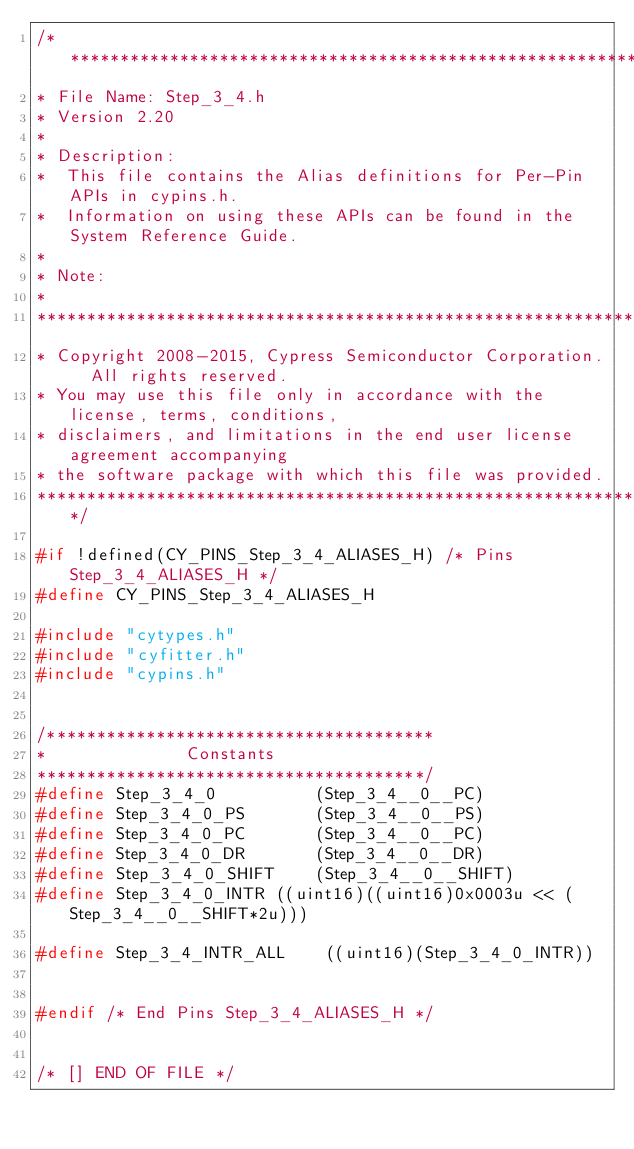Convert code to text. <code><loc_0><loc_0><loc_500><loc_500><_C_>/*******************************************************************************
* File Name: Step_3_4.h  
* Version 2.20
*
* Description:
*  This file contains the Alias definitions for Per-Pin APIs in cypins.h. 
*  Information on using these APIs can be found in the System Reference Guide.
*
* Note:
*
********************************************************************************
* Copyright 2008-2015, Cypress Semiconductor Corporation.  All rights reserved.
* You may use this file only in accordance with the license, terms, conditions, 
* disclaimers, and limitations in the end user license agreement accompanying 
* the software package with which this file was provided.
*******************************************************************************/

#if !defined(CY_PINS_Step_3_4_ALIASES_H) /* Pins Step_3_4_ALIASES_H */
#define CY_PINS_Step_3_4_ALIASES_H

#include "cytypes.h"
#include "cyfitter.h"
#include "cypins.h"


/***************************************
*              Constants        
***************************************/
#define Step_3_4_0			(Step_3_4__0__PC)
#define Step_3_4_0_PS		(Step_3_4__0__PS)
#define Step_3_4_0_PC		(Step_3_4__0__PC)
#define Step_3_4_0_DR		(Step_3_4__0__DR)
#define Step_3_4_0_SHIFT	(Step_3_4__0__SHIFT)
#define Step_3_4_0_INTR	((uint16)((uint16)0x0003u << (Step_3_4__0__SHIFT*2u)))

#define Step_3_4_INTR_ALL	 ((uint16)(Step_3_4_0_INTR))


#endif /* End Pins Step_3_4_ALIASES_H */


/* [] END OF FILE */
</code> 